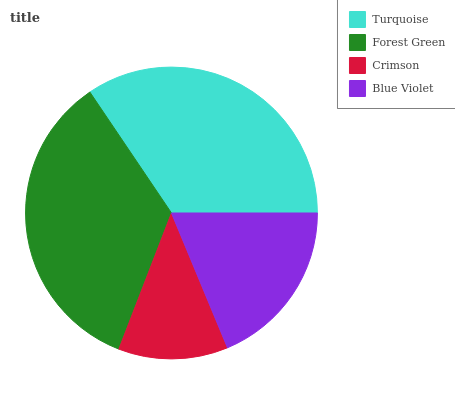Is Crimson the minimum?
Answer yes or no. Yes. Is Forest Green the maximum?
Answer yes or no. Yes. Is Forest Green the minimum?
Answer yes or no. No. Is Crimson the maximum?
Answer yes or no. No. Is Forest Green greater than Crimson?
Answer yes or no. Yes. Is Crimson less than Forest Green?
Answer yes or no. Yes. Is Crimson greater than Forest Green?
Answer yes or no. No. Is Forest Green less than Crimson?
Answer yes or no. No. Is Turquoise the high median?
Answer yes or no. Yes. Is Blue Violet the low median?
Answer yes or no. Yes. Is Blue Violet the high median?
Answer yes or no. No. Is Crimson the low median?
Answer yes or no. No. 